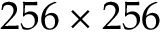Convert formula to latex. <formula><loc_0><loc_0><loc_500><loc_500>2 5 6 \times 2 5 6</formula> 